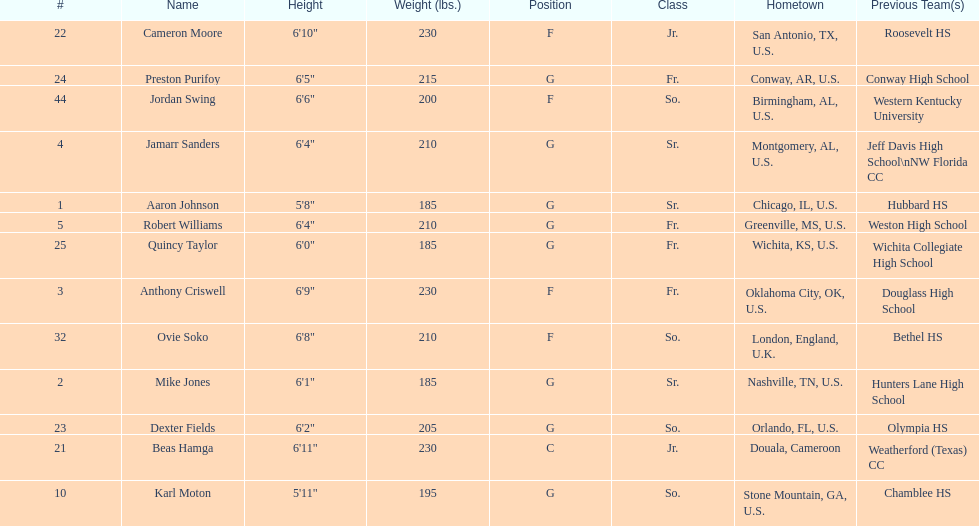What is the number of seniors on the team? 3. 